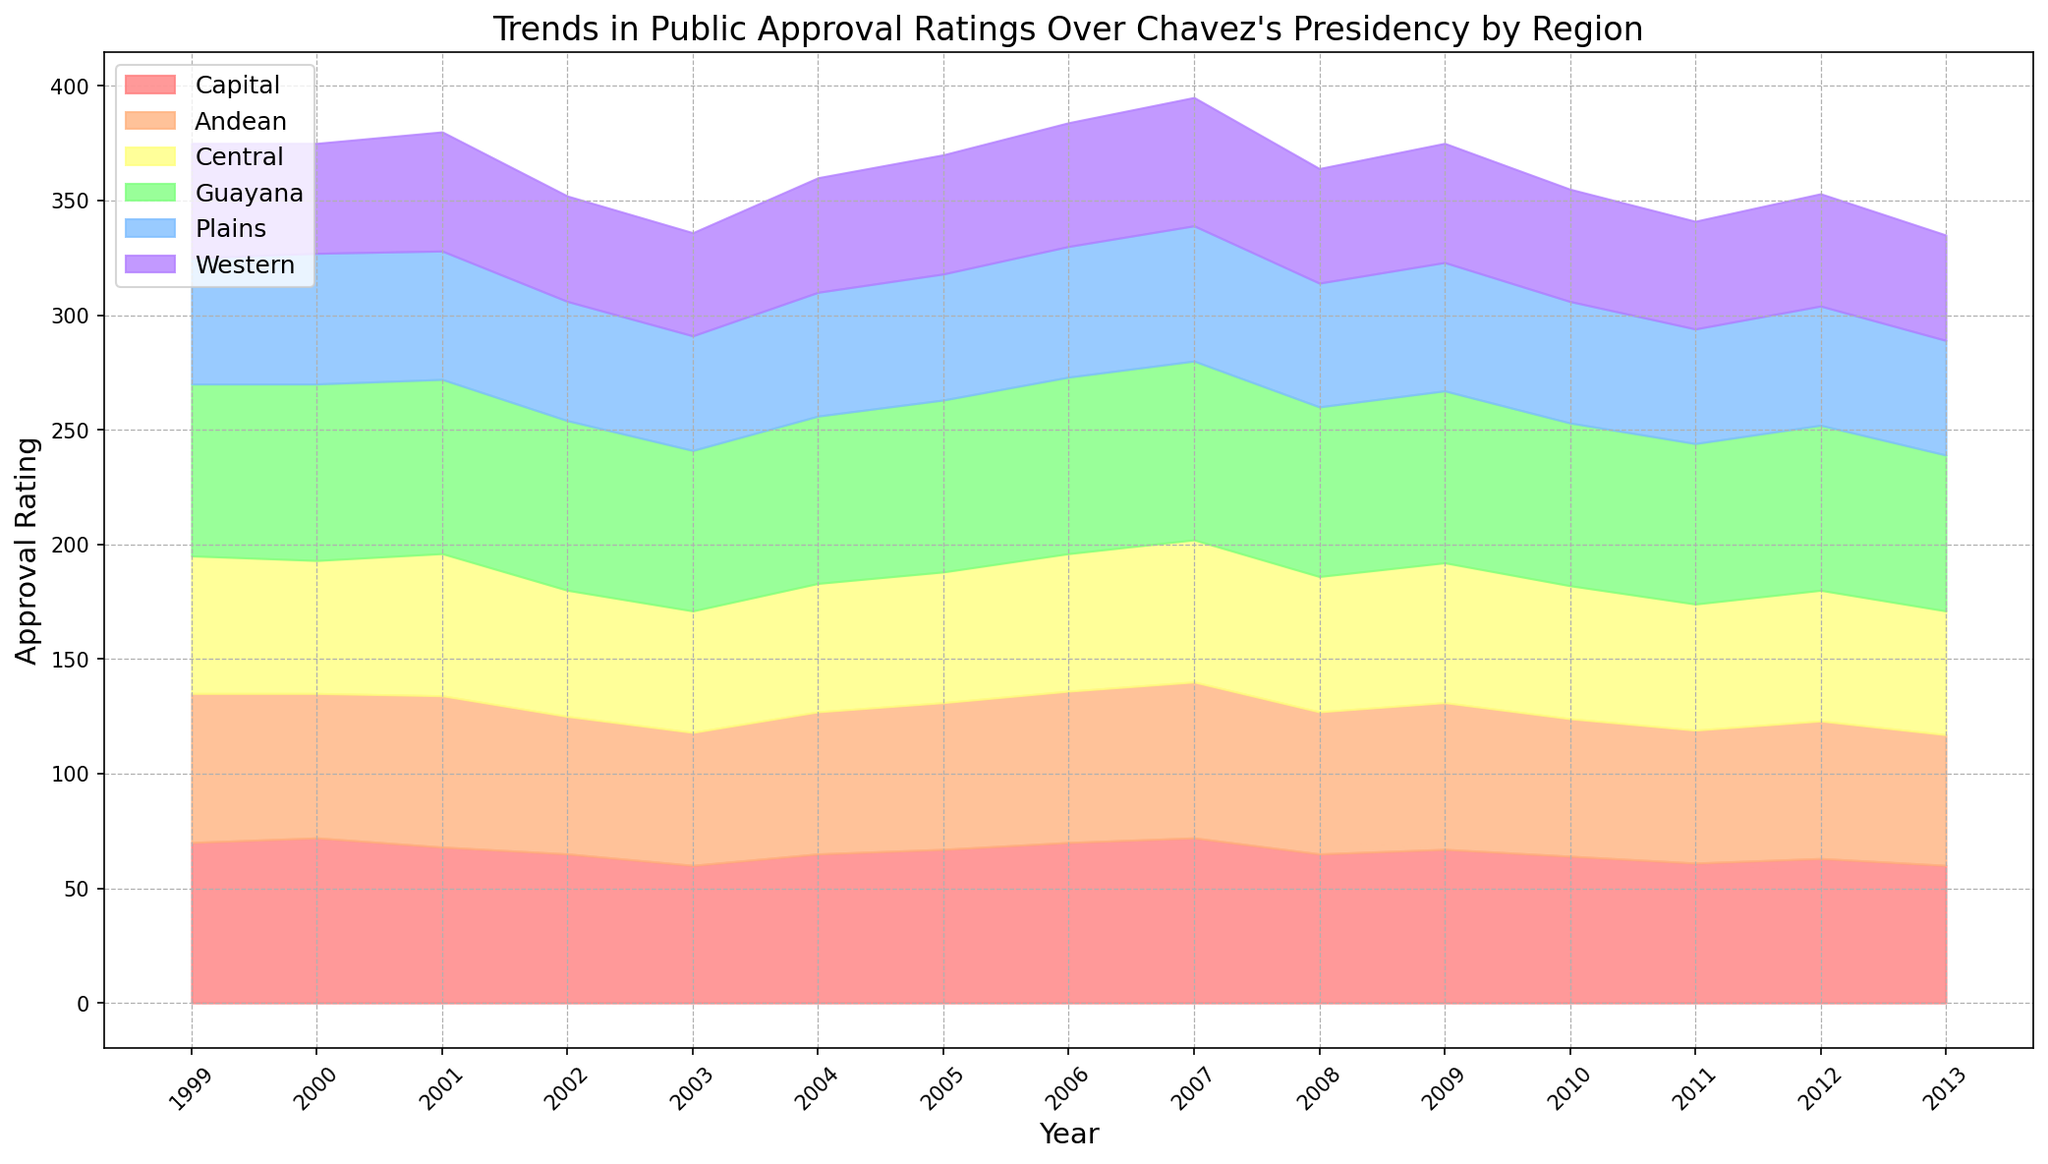Which region had the highest approval rating in 1999? To determine which region had the highest approval rating in 1999, observe the heights of the colored areas for the different regions at the 1999 mark on the x-axis and compare them. The "Guayana" region has the tallest area at that point.
Answer: Guayana How did the approval rating in the Capital region change from 1999 to 2013? To understand the change, look at the height of the red area representing the Capital region at 1999 and compare it to the height in 2013. The rating decreases from 70 in 1999 to 60 in 2013.
Answer: Decreased by 10 points Which year had the lowest overall approval rating across all regions? Summarize the heights of all colored areas for each year and identify the year with the shortest total height. 2013 has the shortest combined height of the areas.
Answer: 2013 Compare the approval ratings of the Central region in 2003 and 2006. Observe the height of the yellow area at the 2003 and 2006 marks on the x-axis. The approval rating in 2003 is lower at 53 compared to 60 in 2006.
Answer: Higher in 2006 By how many points did the approval rating in the Andean region change between 2005 and 2007? Check the heights of the orange area for the Andean region at 2005, which is 64, and compare it to 2007, which is 68. The increase is calculated as 68 - 64.
Answer: Increased by 4 points What is the average approval rating of the Guayana region over Chavez’s entire presidency? Add the approval ratings for Guayana from 1999 to 2013 and divide by the number of years (15). (75+77+76+74+70+73+75+77+78+74+75+71+70+72+68) / 15 ≈ 73.07
Answer: Approximately 73.07 In which year did the Plains region experience the highest approval rating? Compare the heights of the green area for the Plains region across all years and identify the tallest. The highest height is in 2007 at 59 points.
Answer: 2007 Which region shows the most fluctuation in approval ratings throughout the years? Look at which colored area changes the most in height from year to year. The Capital region (red) shows notable fluctuations, decreasing significantly around mid-period before stabilizing.
Answer: Capital From 1999 to 2013, did the Western region approval rating generally increase, decrease, or remain stable? Compare the height of the purple area from the start in 1999 to the end in 2013. The Western region rating starts at 50 and ends at 46, showing an overall decrease.
Answer: Decrease 